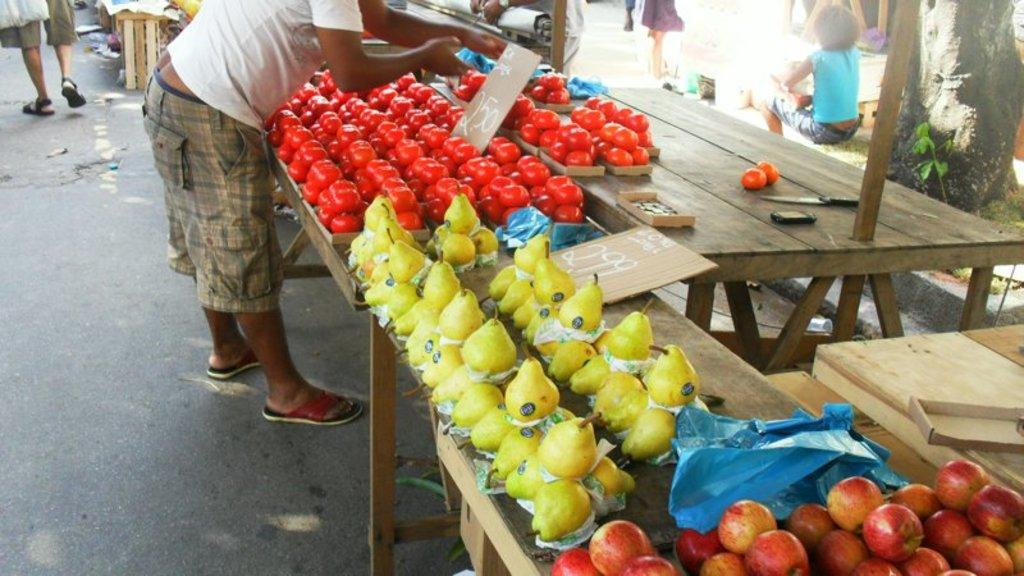What is placed on the wooden table in the image? There are fruits on a wooden table in the image. What type of material is used for the boards visible in the image? The boards visible in the image are made of wood. What tool is present in the image that might be used for cutting? A knife is present in the image. Can you describe the people in the image? There are people in the image, but their specific actions or characteristics are not mentioned in the provided facts. What type of vegetation is on the right side of the image? There is a tree on the right side of the image. What type of nerve can be seen in the image? There is no nerve present in the image. What is the selection of fruits available on the table in the image? The provided facts do not specify the types of fruits on the table, so we cannot answer this question definitively. 